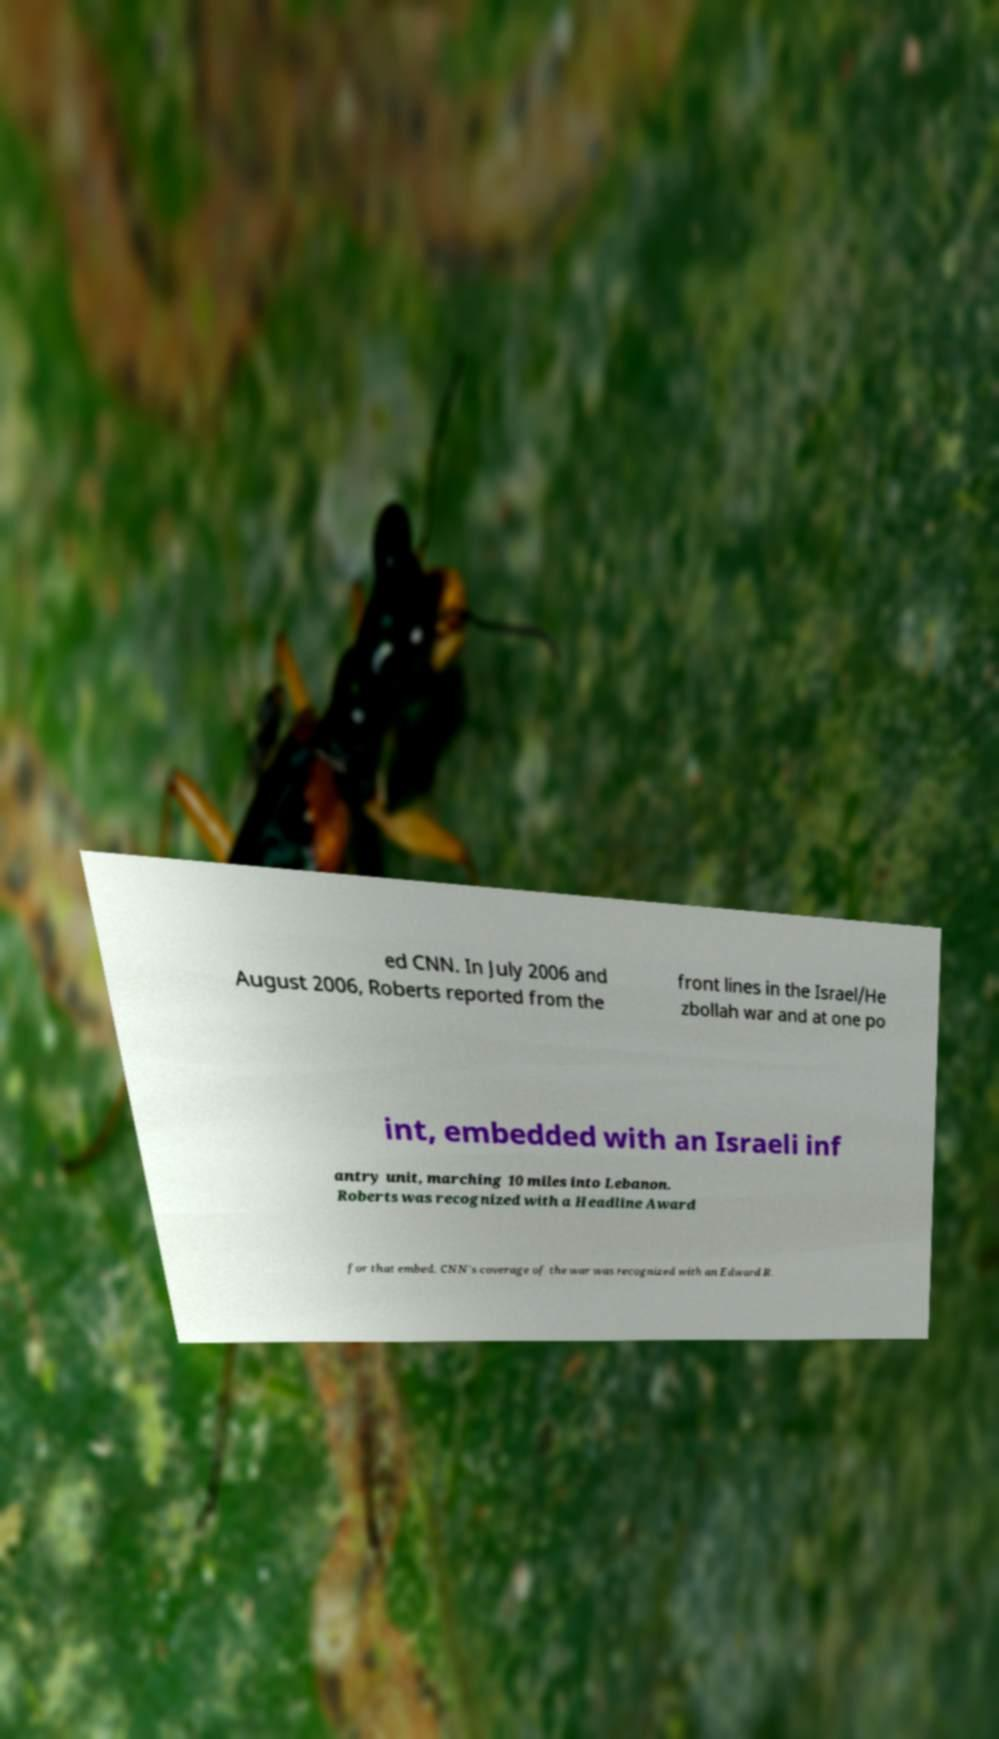Could you assist in decoding the text presented in this image and type it out clearly? ed CNN. In July 2006 and August 2006, Roberts reported from the front lines in the Israel/He zbollah war and at one po int, embedded with an Israeli inf antry unit, marching 10 miles into Lebanon. Roberts was recognized with a Headline Award for that embed. CNN's coverage of the war was recognized with an Edward R. 